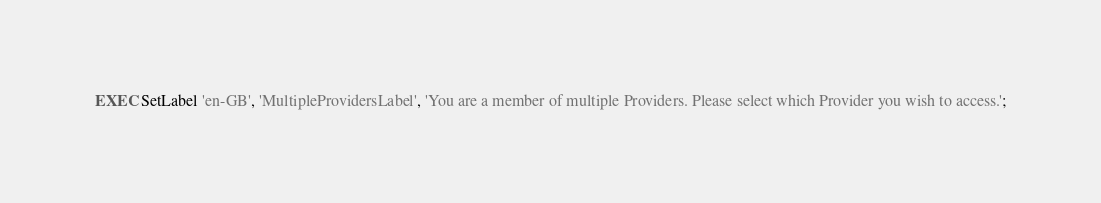Convert code to text. <code><loc_0><loc_0><loc_500><loc_500><_SQL_>EXEC SetLabel 'en-GB', 'MultipleProvidersLabel', 'You are a member of multiple Providers. Please select which Provider you wish to access.';</code> 